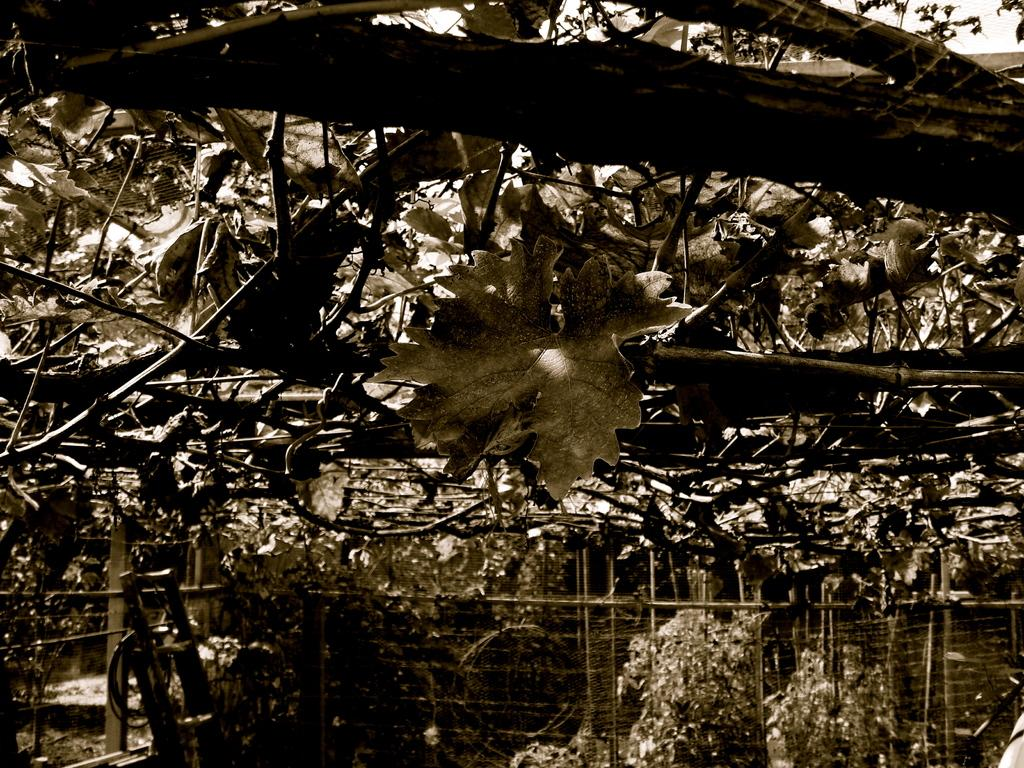What type of vegetation can be seen in the image? There are trees and garden plants in the image. What object might be used for reaching higher places in the image? There is a small ladder in the image. What type of barrier is present in the image? There is a fence in the image. What type of acoustics can be heard from the rabbits in the image? There are no rabbits present in the image, so it is not possible to determine the acoustics. 